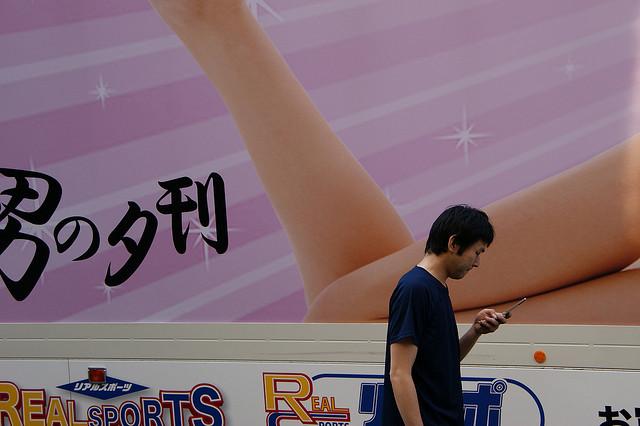What is the man looking at?
Be succinct. Cell phone. What does the sign say?
Give a very brief answer. Real sports. Are there any advertisements?
Be succinct. Yes. Is the writing on the billboard English?
Write a very short answer. No. What hand is she holding the cell phone with?
Answer briefly. Left. What words are painted on the wall?
Write a very short answer. Real sports. What color is the cell phone?
Answer briefly. Silver. 